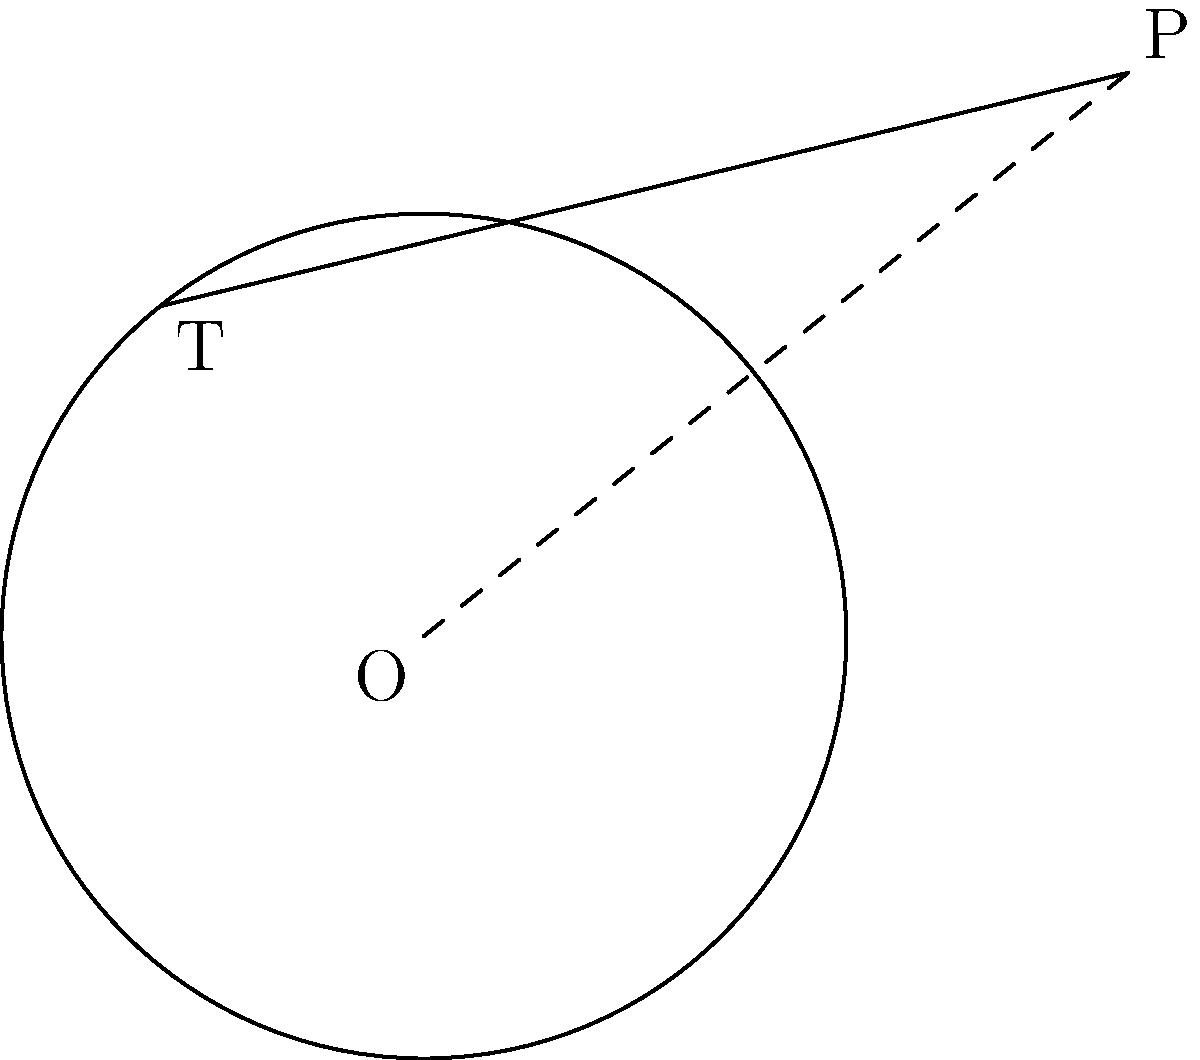At the Jinichiro Kozuma Golf Academy, a circular putting green has a radius of 3 meters. You're standing at point P, which is 5 meters from the center of the green. If you were to roll a ball that just grazes the edge of the green, how long would the path of the ball be from your position to the point where it touches the green? Let's approach this step-by-step:

1) Let O be the center of the circle (putting green), P be your position, and T be the point where the ball touches the green.

2) We know:
   - Radius of the circle (r) = 3 meters
   - Distance from P to O (d) = 5 meters

3) In a right-angled triangle OPT:
   - OT is perpendicular to PT (tangent property)
   - OT = r = 3 (radius)
   - OP = d = 5

4) We can use the Pythagorean theorem:
   $PT^2 + OT^2 = OP^2$

5) Substituting the known values:
   $PT^2 + 3^2 = 5^2$

6) Simplify:
   $PT^2 + 9 = 25$

7) Solve for PT:
   $PT^2 = 25 - 9 = 16$
   $PT = \sqrt{16} = 4$

Therefore, the length of the tangent line (the path of the ball) from your position to the edge of the green is 4 meters.
Answer: 4 meters 